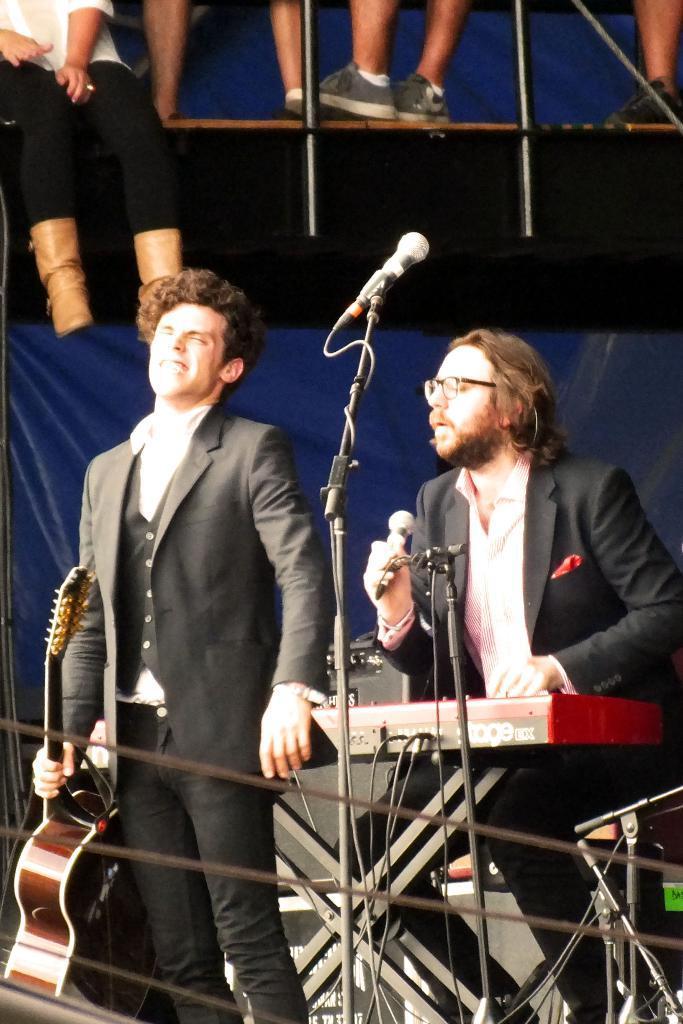Can you describe this image briefly? In this image on the left side a man is standing and holding a guitar in his hand and on the right side another man is holding a mic in his hand and there are microphones on the stands, device on a stand. In the background we can see legs of few persons and objects. 